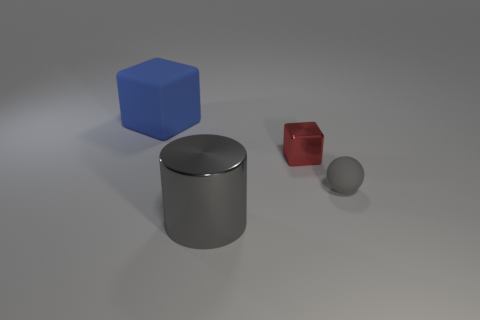Add 3 small red cubes. How many objects exist? 7 Subtract all blue cubes. How many cubes are left? 1 Subtract all balls. How many objects are left? 3 Subtract 1 blocks. How many blocks are left? 1 Add 4 small red shiny things. How many small red shiny things are left? 5 Add 3 large gray matte things. How many large gray matte things exist? 3 Subtract 0 brown cubes. How many objects are left? 4 Subtract all yellow cylinders. Subtract all blue cubes. How many cylinders are left? 1 Subtract all matte cylinders. Subtract all blue rubber blocks. How many objects are left? 3 